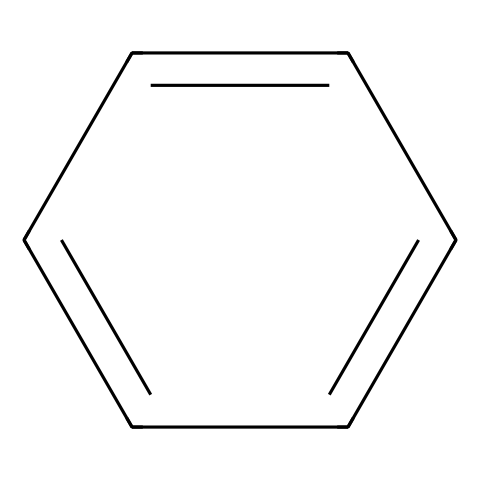how many carbon atoms are in the structure? The SMILES representation indicates a ring structure, and by analyzing the formula derived from the SMILES, we can see that it contains six carbon atoms arranged in a cyclic fashion.
Answer: six what type of bond is present in this chemical structure? The chemical structure consists primarily of carbon-carbon double bonds, indicating the presence of alkenes. The presence of alternating double bonds shows that it is an aromatic compound.
Answer: double what is the name of the chemical represented by this SMILES? Based on the structure indicated by the SMILES, it corresponds to benzene, which is found in various aromatic compounds.
Answer: benzene how many pi bonds are present in this compound? In the structure, each carbon-carbon double bond represents a pi bond. Analyzing the SMILES, there are three double bonds in the ring, leading to a total of three pi bonds.
Answer: three what is the primary function of this chemical in psychotropic drug formulation? Benzene and its derivatives are often used as foundational structures in the design of various psychotropic drugs due to their unique properties, such as stability, and ability to interact with biological systems.
Answer: foundational structure what property does the cyclic structure impart to the reactivity of this drug? The cyclic structure contributes to the stability and unique reactivity of the compound, making it less reactive than open-chain alkenes, which can lead to more controlled pharmacological effects.
Answer: stability 